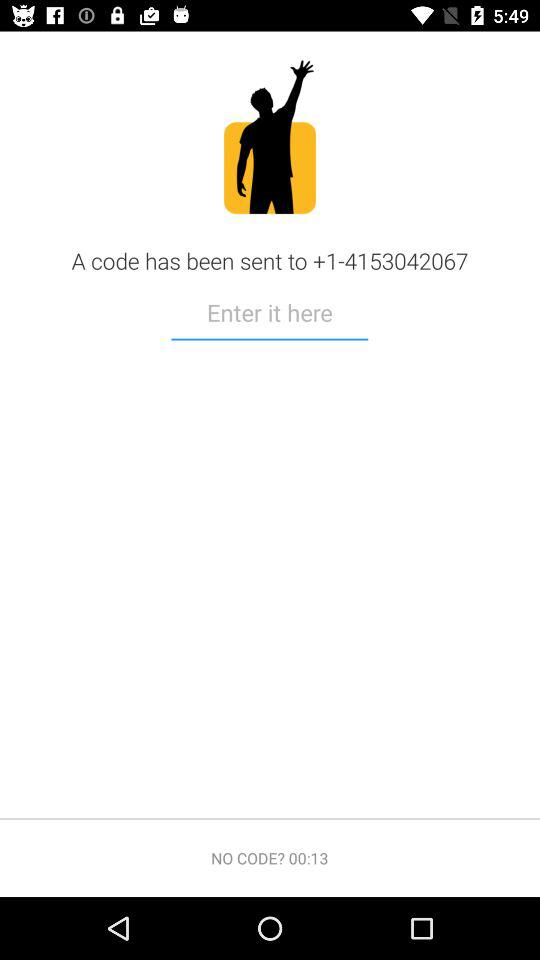On what number has the code been sent? The number is +1-4153042067. 